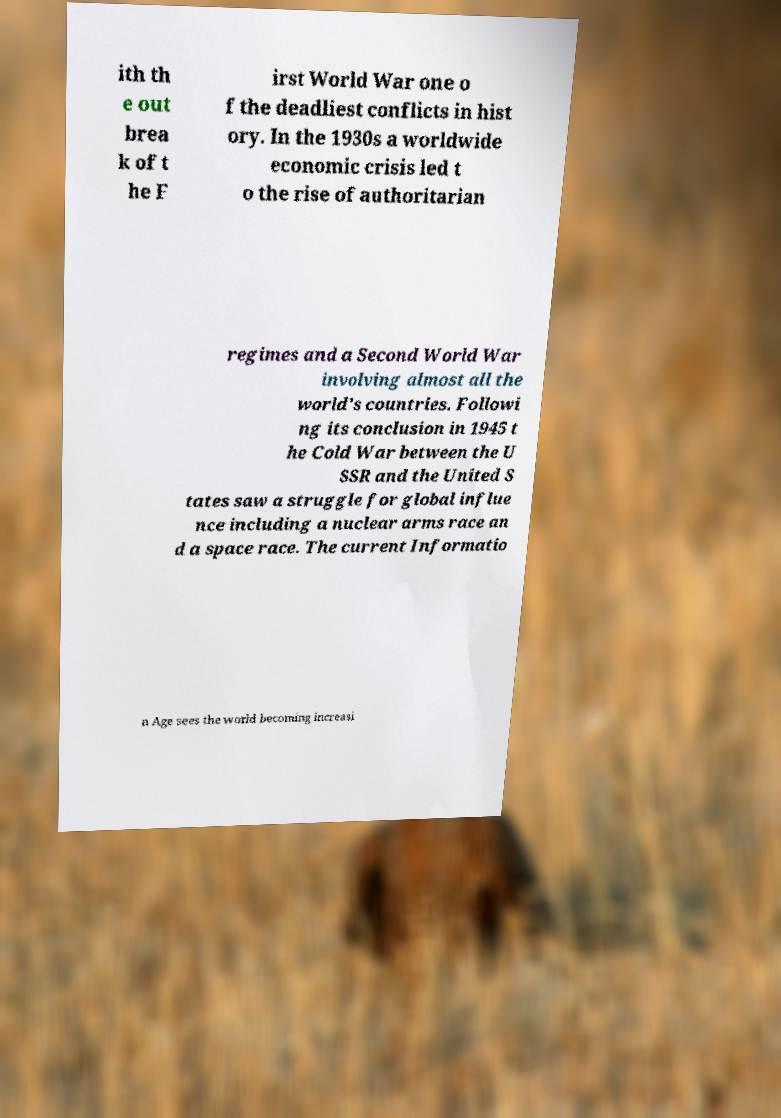Could you extract and type out the text from this image? ith th e out brea k of t he F irst World War one o f the deadliest conflicts in hist ory. In the 1930s a worldwide economic crisis led t o the rise of authoritarian regimes and a Second World War involving almost all the world's countries. Followi ng its conclusion in 1945 t he Cold War between the U SSR and the United S tates saw a struggle for global influe nce including a nuclear arms race an d a space race. The current Informatio n Age sees the world becoming increasi 